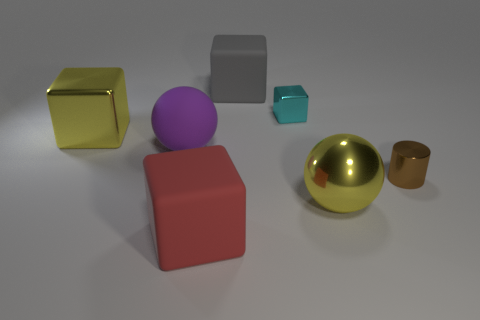Subtract 2 blocks. How many blocks are left? 2 Subtract all red blocks. How many blocks are left? 3 Subtract all gray rubber cubes. How many cubes are left? 3 Add 1 brown cylinders. How many objects exist? 8 Subtract all purple blocks. Subtract all purple spheres. How many blocks are left? 4 Subtract all balls. How many objects are left? 5 Add 7 tiny brown things. How many tiny brown things exist? 8 Subtract 0 green cylinders. How many objects are left? 7 Subtract all metallic cubes. Subtract all yellow objects. How many objects are left? 3 Add 7 yellow spheres. How many yellow spheres are left? 8 